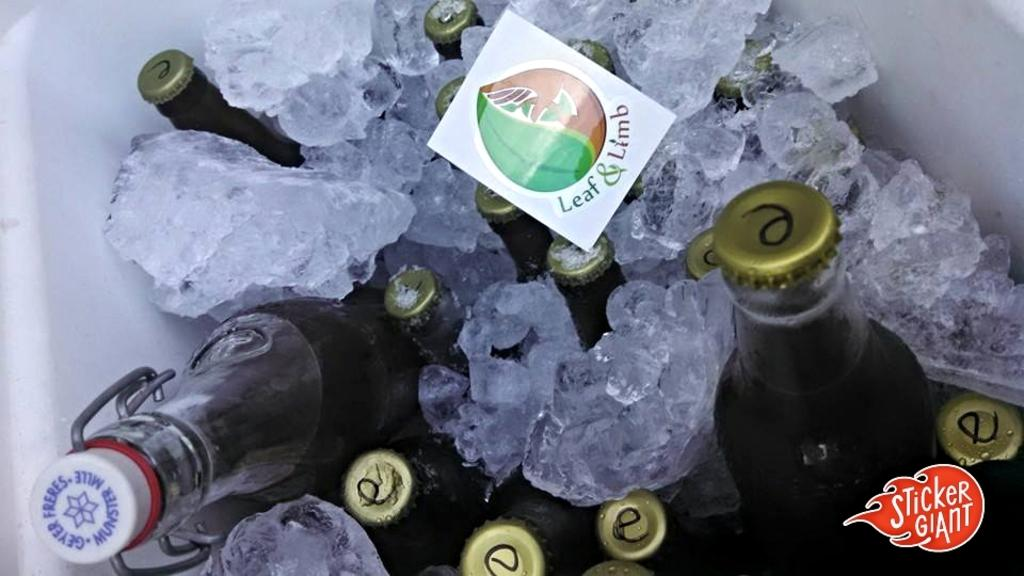<image>
Relay a brief, clear account of the picture shown. A cooler full of ice and glass bottles has a Leaf & Limb sticker on top of one of them. 